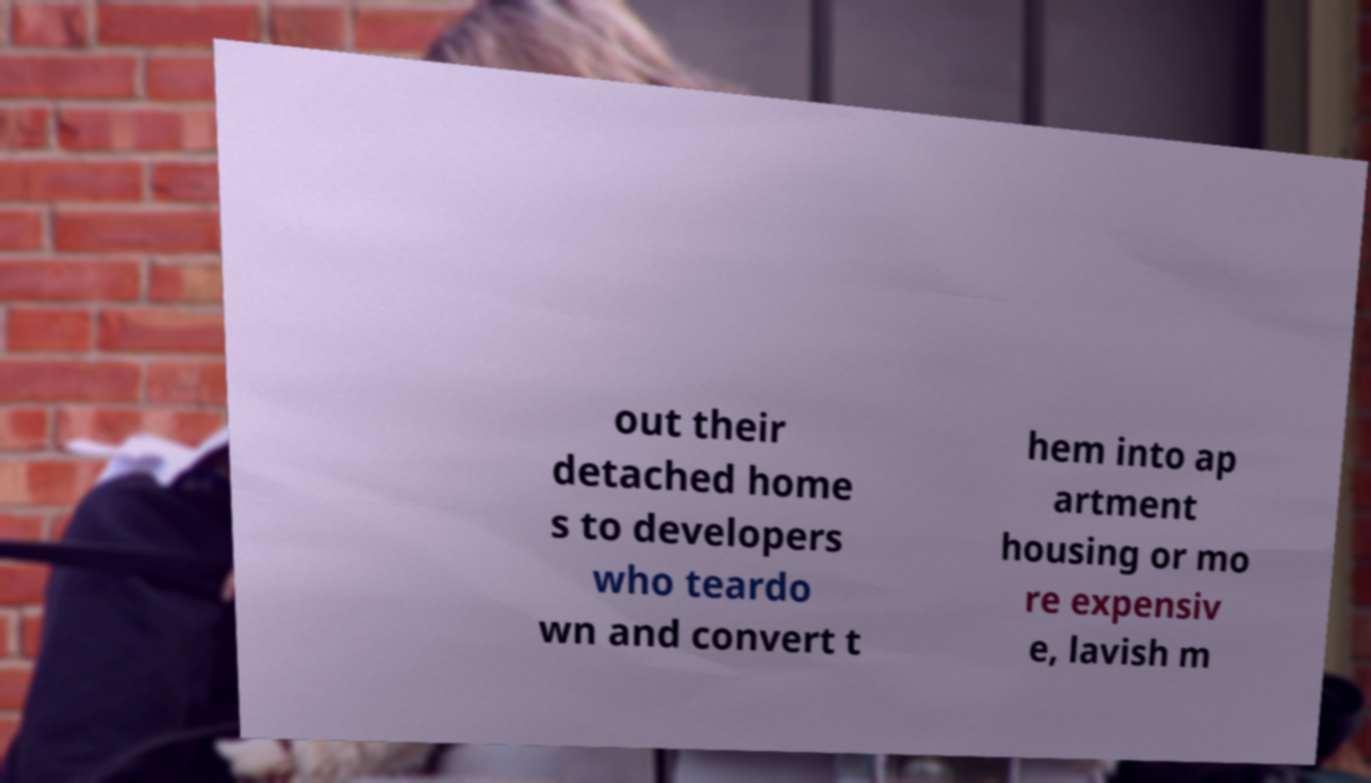Can you read and provide the text displayed in the image?This photo seems to have some interesting text. Can you extract and type it out for me? out their detached home s to developers who teardo wn and convert t hem into ap artment housing or mo re expensiv e, lavish m 